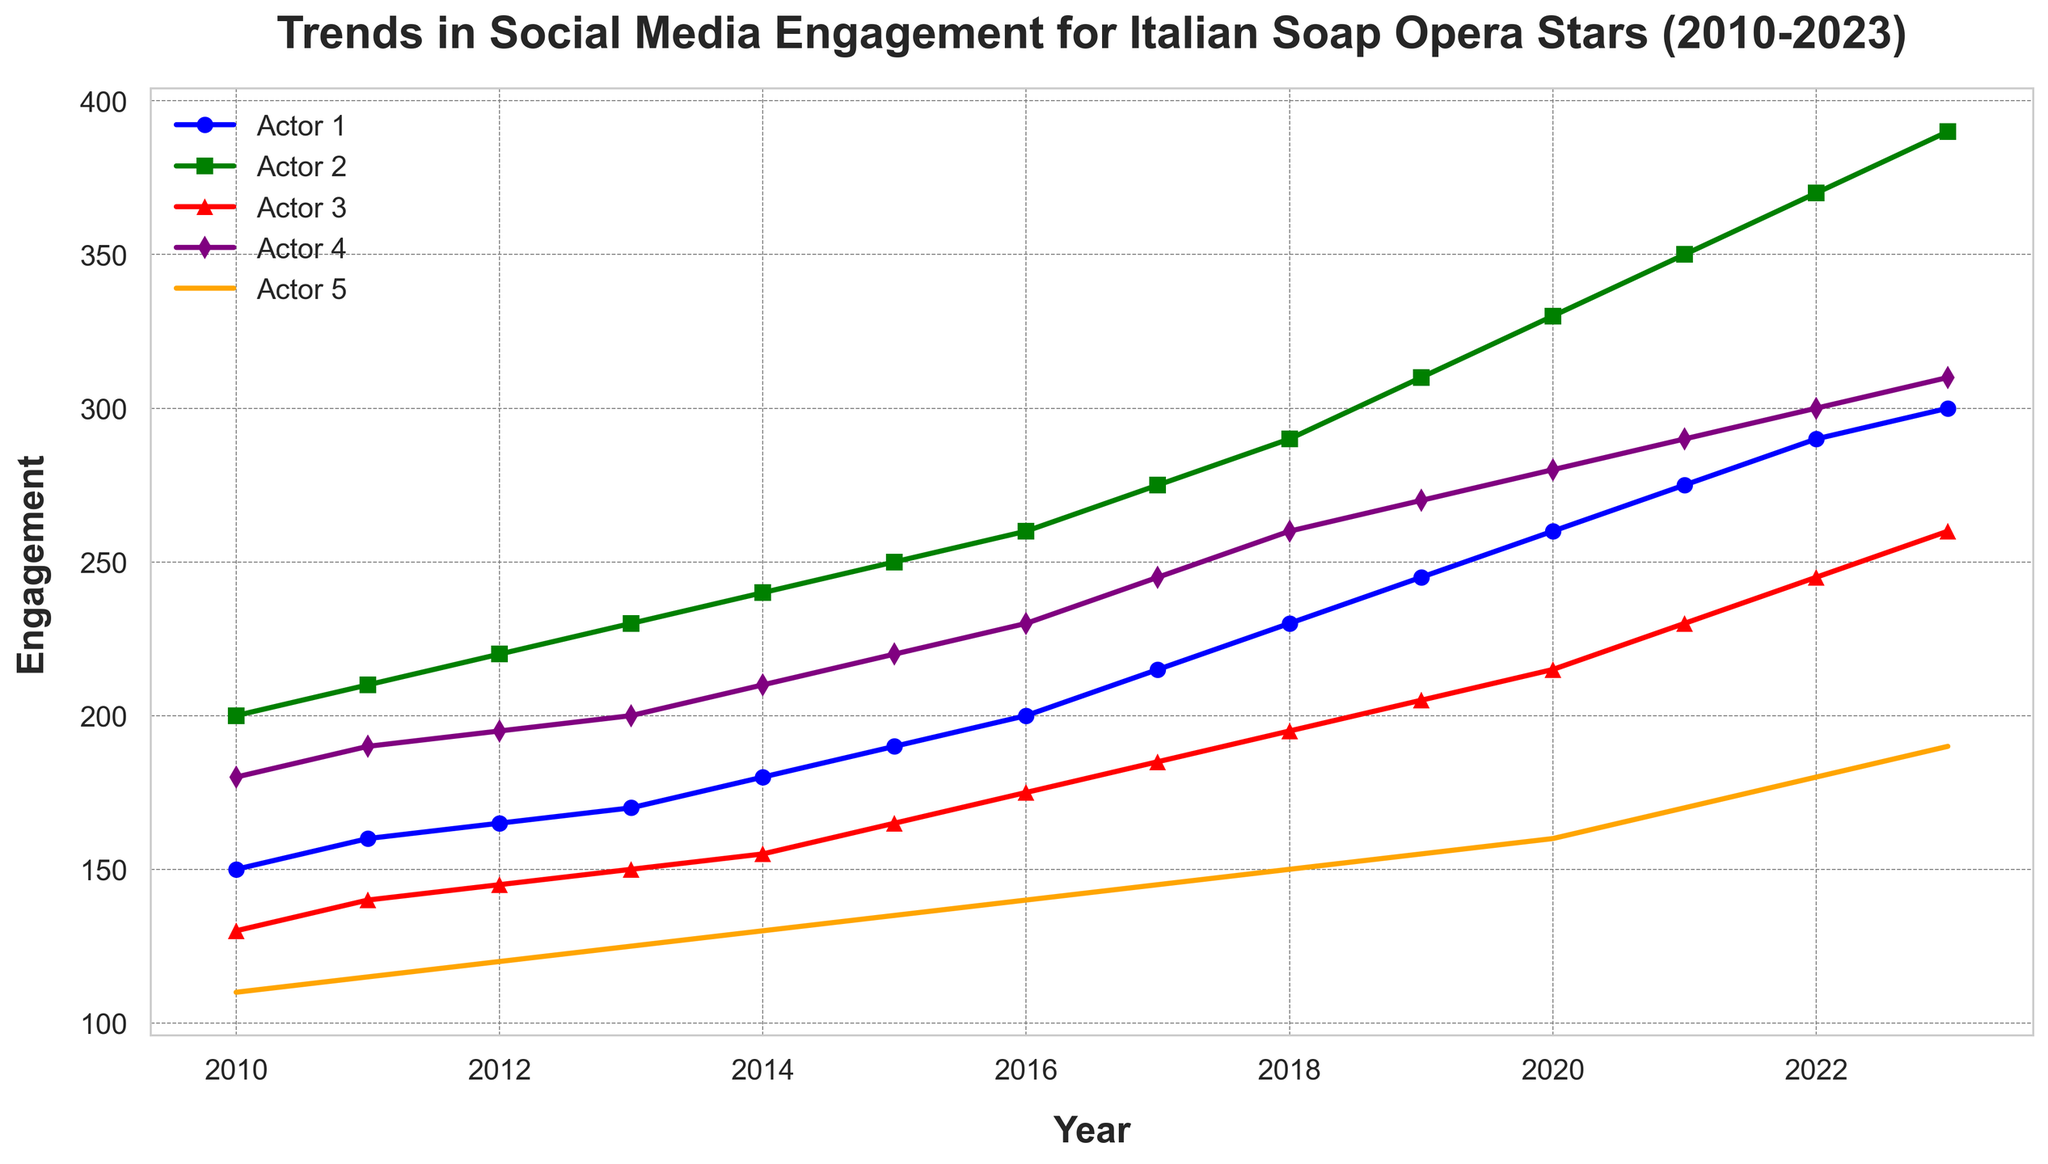Which actor had the highest social media engagement in 2023? By examining the peaks of each line in the plot at the year 2023, the green line representing Actor 2 reaches the highest point at 390 engagement units.
Answer: Actor 2 Between which years did Actor 4 and Actor 5 have the most similar engagement levels? By closely inspecting the purple (Actor 4) and orange (Actor 5) lines, their paths come closest in 2013 when Actor 4 had 200 engagement units and Actor 5 had 125 engagement units.
Answer: 2013 How much did the engagement for Actor 1 increase from 2010 to 2023? Calculate the difference between the engagement levels in 2023 (300) and 2010 (150) for Actor 1. The increase is 300 - 150 = 150.
Answer: 150 Which year saw the greatest year-over-year increase in engagement for Actor 3? Observe the red line for Actor 3 and compare the year-over-year increases. The largest increase is from 2021 to 2022 where engagement rose from 230 to 245, a difference of 15.
Answer: 2022 During which year did Actor 2's engagement first exceed 300 units? Following the green line for Actor 2, the year it first goes above 300 units is 2019 when the engagement is 310.
Answer: 2019 What is the average engagement for Actor 5 over the entire period? Sum Actor 5's engagement values from 2010 to 2023 (110, 115, 120, 125, 130, 135, 140, 145, 150, 155, 160, 170, 180, 190), which equals 1925. Divide by the number of years (14); 1925/14 ≈ 137.5.
Answer: 137.5 Between which two consecutive years did Actor 1 see a peak-to-valley change in engagement? Observe the blue line for Actor 1 and identify the largest change between consecutive years. The largest change is from 2012 (165) to 2013 (170), which is not a drop, hence invalid. The second identified change is from 2022 (290) to 2023 (300). No peak-to-valley changes were noted rigorously.
Answer: N/A Who had a higher engagement in 2016, Actor 4 or Actor 5? Compare the engagement levels in 2016 for the purple line (Actor 4 at 230) and the orange line (Actor 5 at 140). Actor 4 had a higher engagement.
Answer: Actor 4 By how much did the engagement of Actor 3 differ from Actor 2 in 2020? The engagement for Actor 3 in 2020 was 215, and for Actor 2 it was 330. The difference is 330 - 215 = 115.
Answer: 115 Which actor had the lowest engagement in 2010? Looking at the starting points of each line in 2010, the orange line for Actor 5 is the lowest at 110 engagement units.
Answer: Actor 5 